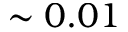Convert formula to latex. <formula><loc_0><loc_0><loc_500><loc_500>\sim 0 . 0 1</formula> 